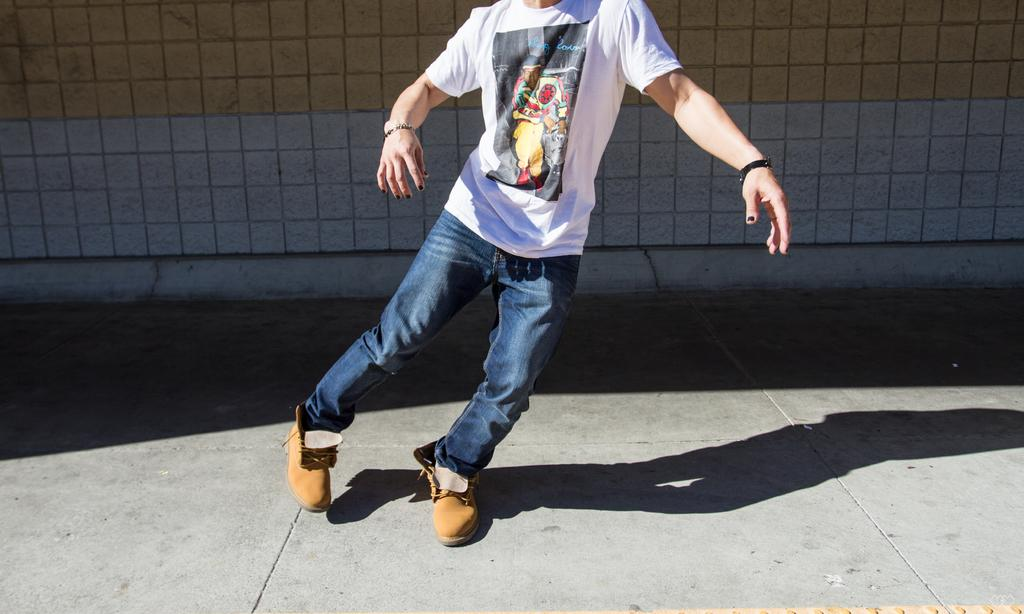What is the main subject in the foreground of the image? There is a person in the foreground of the image. What can be seen in the background of the image? There is a wall in the background of the image. What type of riddle is the person in the image trying to solve? There is no riddle present in the image, as it only features a person and a wall in the background. 